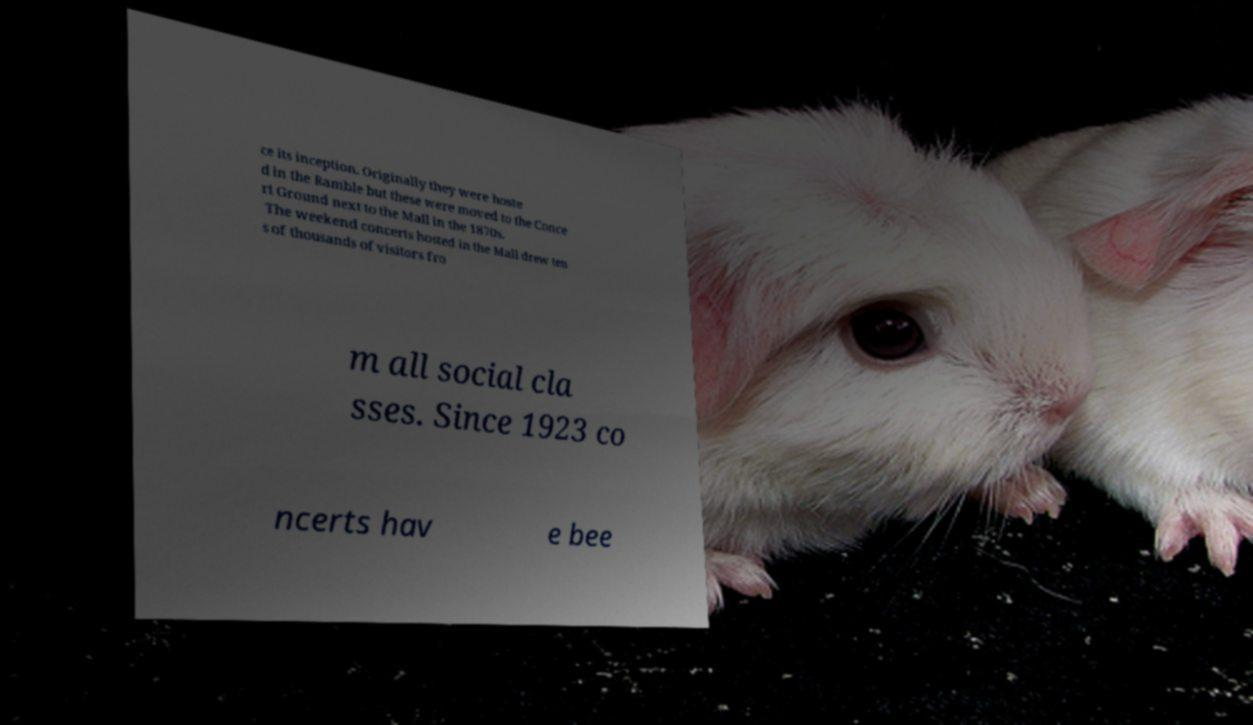Can you accurately transcribe the text from the provided image for me? ce its inception. Originally they were hoste d in the Ramble but these were moved to the Conce rt Ground next to the Mall in the 1870s. The weekend concerts hosted in the Mall drew ten s of thousands of visitors fro m all social cla sses. Since 1923 co ncerts hav e bee 